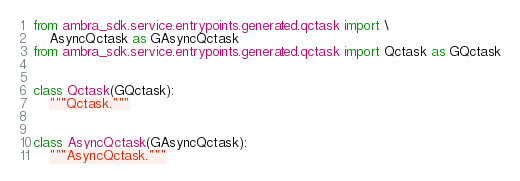Convert code to text. <code><loc_0><loc_0><loc_500><loc_500><_Python_>from ambra_sdk.service.entrypoints.generated.qctask import \
    AsyncQctask as GAsyncQctask
from ambra_sdk.service.entrypoints.generated.qctask import Qctask as GQctask


class Qctask(GQctask):
    """Qctask."""


class AsyncQctask(GAsyncQctask):
    """AsyncQctask."""
</code> 